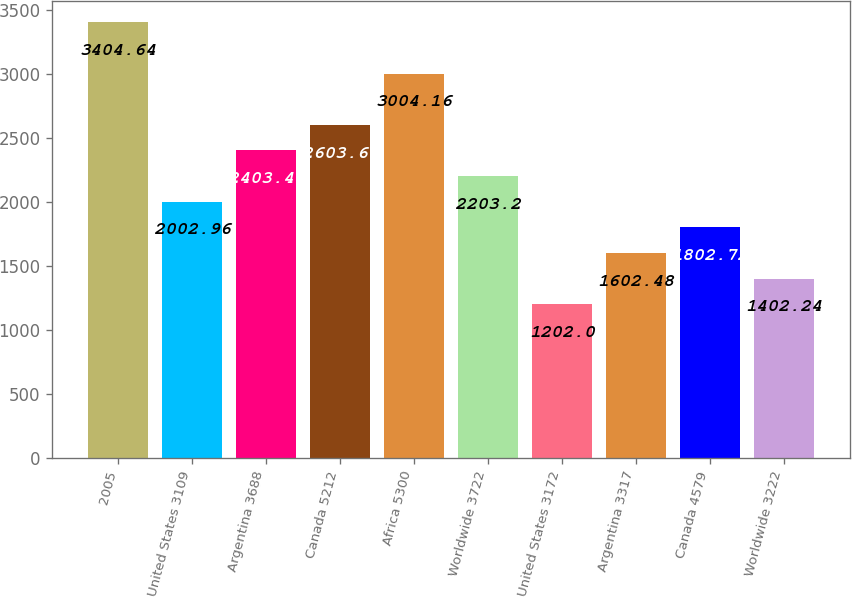<chart> <loc_0><loc_0><loc_500><loc_500><bar_chart><fcel>2005<fcel>United States 3109<fcel>Argentina 3688<fcel>Canada 5212<fcel>Africa 5300<fcel>Worldwide 3722<fcel>United States 3172<fcel>Argentina 3317<fcel>Canada 4579<fcel>Worldwide 3222<nl><fcel>3404.64<fcel>2002.96<fcel>2403.44<fcel>2603.68<fcel>3004.16<fcel>2203.2<fcel>1202<fcel>1602.48<fcel>1802.72<fcel>1402.24<nl></chart> 